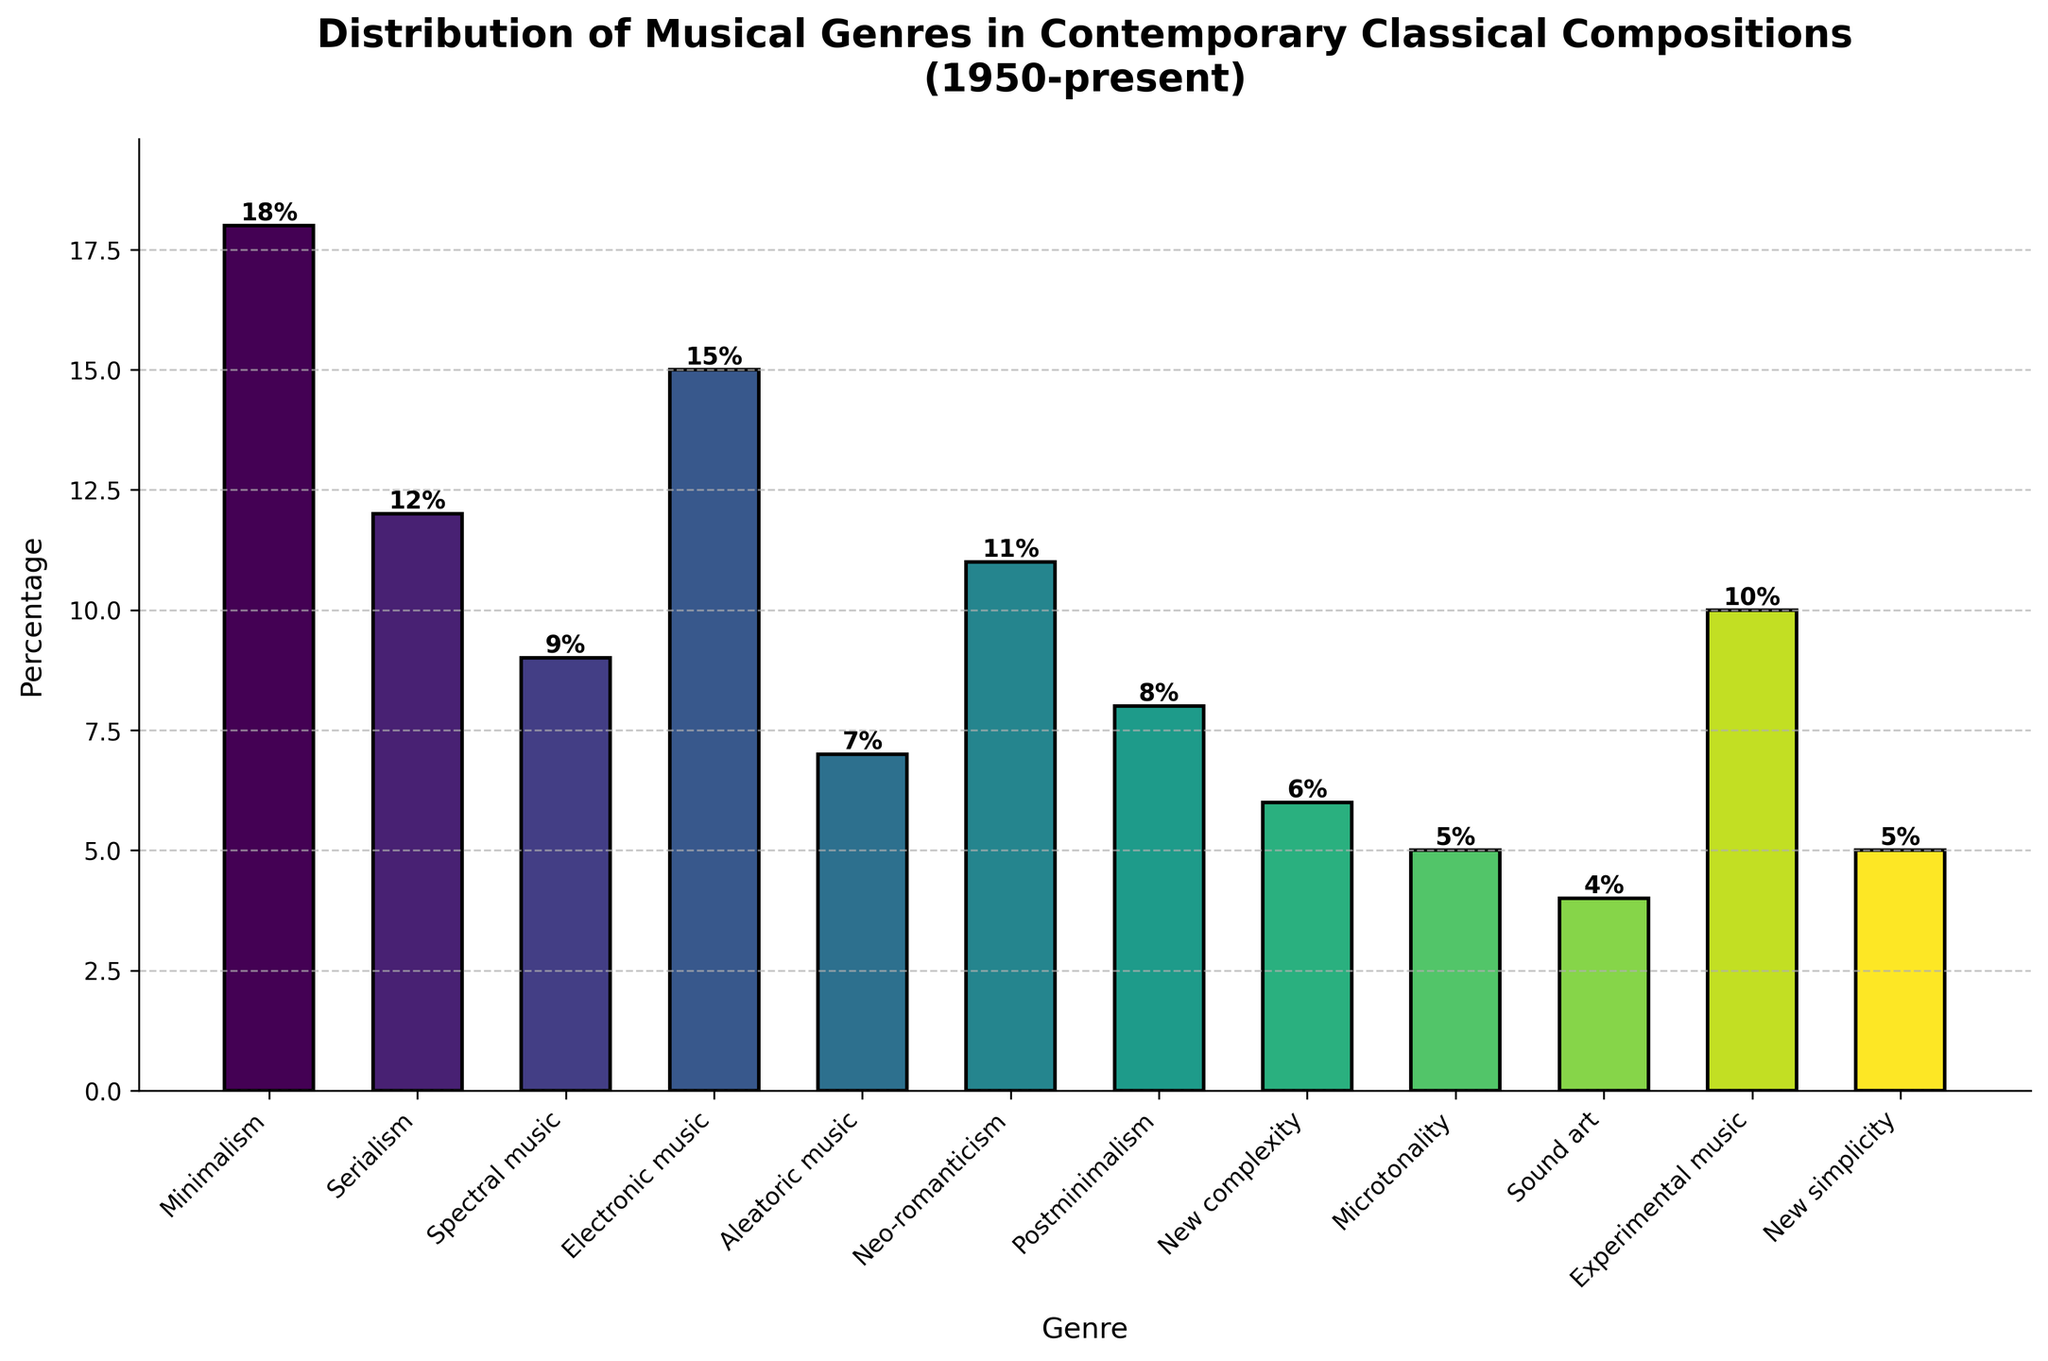What is the difference in percentage between Minimalism and Aleatoric music? Minimalism is at 18% and Aleatoric music is at 7%. The difference is calculated by subtracting the percentage of Aleatoric music from Minimalism: 18% - 7% = 11%.
Answer: 11% Which genre has the highest percentage and which has the lowest? The highest percentage is 18%, which corresponds to Minimalism. The lowest percentage is 4%, which corresponds to Sound art.
Answer: Minimalism (highest), Sound art (lowest) What is the combined percentage of Genres with a percentage higher than 10%? The genres with percentages higher than 10% are Minimalism (18%), Serialism (12%), and Electronic music (15%). Adding these: 18% + 12% + 15% = 45%.
Answer: 45% How much higher is the percentage of Neo-romanticism compared to New simplicity? Neo-romanticism is at 11% while New simplicity is at 5%. The difference is: 11% - 5% = 6%.
Answer: 6% What is the average percentage of Postminimalism, Experimental music, and Microtonality? The percentages are Postminimalism (8%), Experimental music (10%), and Microtonality (5%). The average is calculated as (8% + 10% + 5%) / 3 = 7.67%.
Answer: 7.67% If you combine the percentages of New complexity and Sound art, do they surpass Aleatoric music? New complexity is at 6% and Sound art at 4%, combined they are 6% + 4% = 10%. Aleatoric music is at 7%. Since 10% is greater than 7%, they do surpass Aleatoric music.
Answer: Yes Which genres are in the middle percentage range, specifically between 5% and 10% inclusive? The genres within the 5% to 10% range are Spectral music (9%), Postminimalism (8%), New complexity (6%), Microtonality (5%), and New simplicity (5%).
Answer: Spectral music, Postminimalism, New complexity, Microtonality, New simplicity Are there more genres with percentages above or below 10%? To determine this, count the genres: above 10% are Minimalism, Serialism, Electronic music, and Neo-romanticism (4 genres). Below 10% are Spectral music, Postminimalism, New complexity, Microtonality, Sound art, Experimental music, New simplicity, and Aleatoric music (8 genres).
Answer: Below 10% Which genres have similar percentage values, specifically within 1% of each other? Postminimalism is at 8% and Spectral music is at 9%, within 1%. New complexity is at 6% and Aleatoric music is at 7%, also within 1%.
Answer: Spectral music and Postminimalism, Aleatoric music and New complexity 